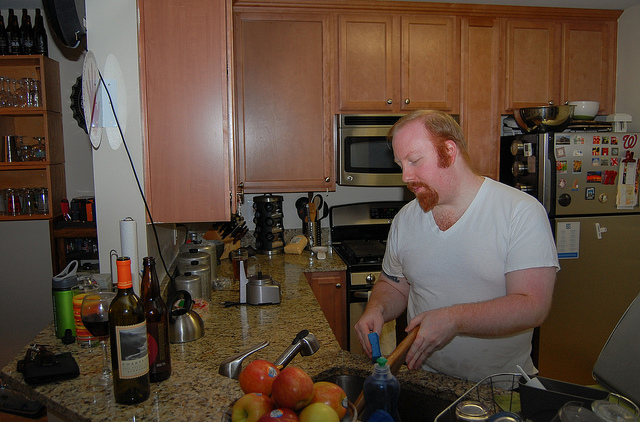How many stoves are there? There is one stove visible in the image, situated between the countertop and the wooden cabinets. It appears to be a standard home kitchen range with a stovetop and oven combination, essential for cooking and baking. 